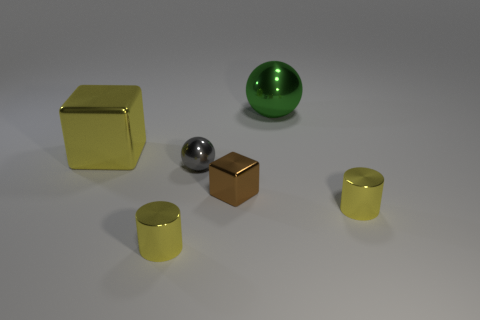Add 2 big balls. How many objects exist? 8 Add 4 small gray balls. How many small gray balls exist? 5 Subtract 0 gray cylinders. How many objects are left? 6 Subtract all red metal balls. Subtract all small things. How many objects are left? 2 Add 2 big yellow cubes. How many big yellow cubes are left? 3 